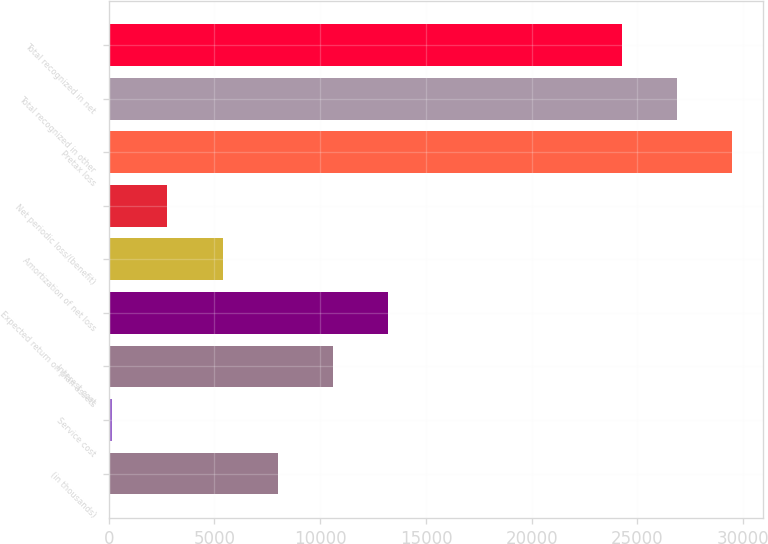<chart> <loc_0><loc_0><loc_500><loc_500><bar_chart><fcel>(in thousands)<fcel>Service cost<fcel>Interest cost<fcel>Expected return on plan assets<fcel>Amortization of net loss<fcel>Net periodic loss/(benefit)<fcel>Pretax loss<fcel>Total recognized in other<fcel>Total recognized in net<nl><fcel>7999.7<fcel>158<fcel>10613.6<fcel>13227.5<fcel>5385.8<fcel>2771.9<fcel>29481.8<fcel>26867.9<fcel>24254<nl></chart> 